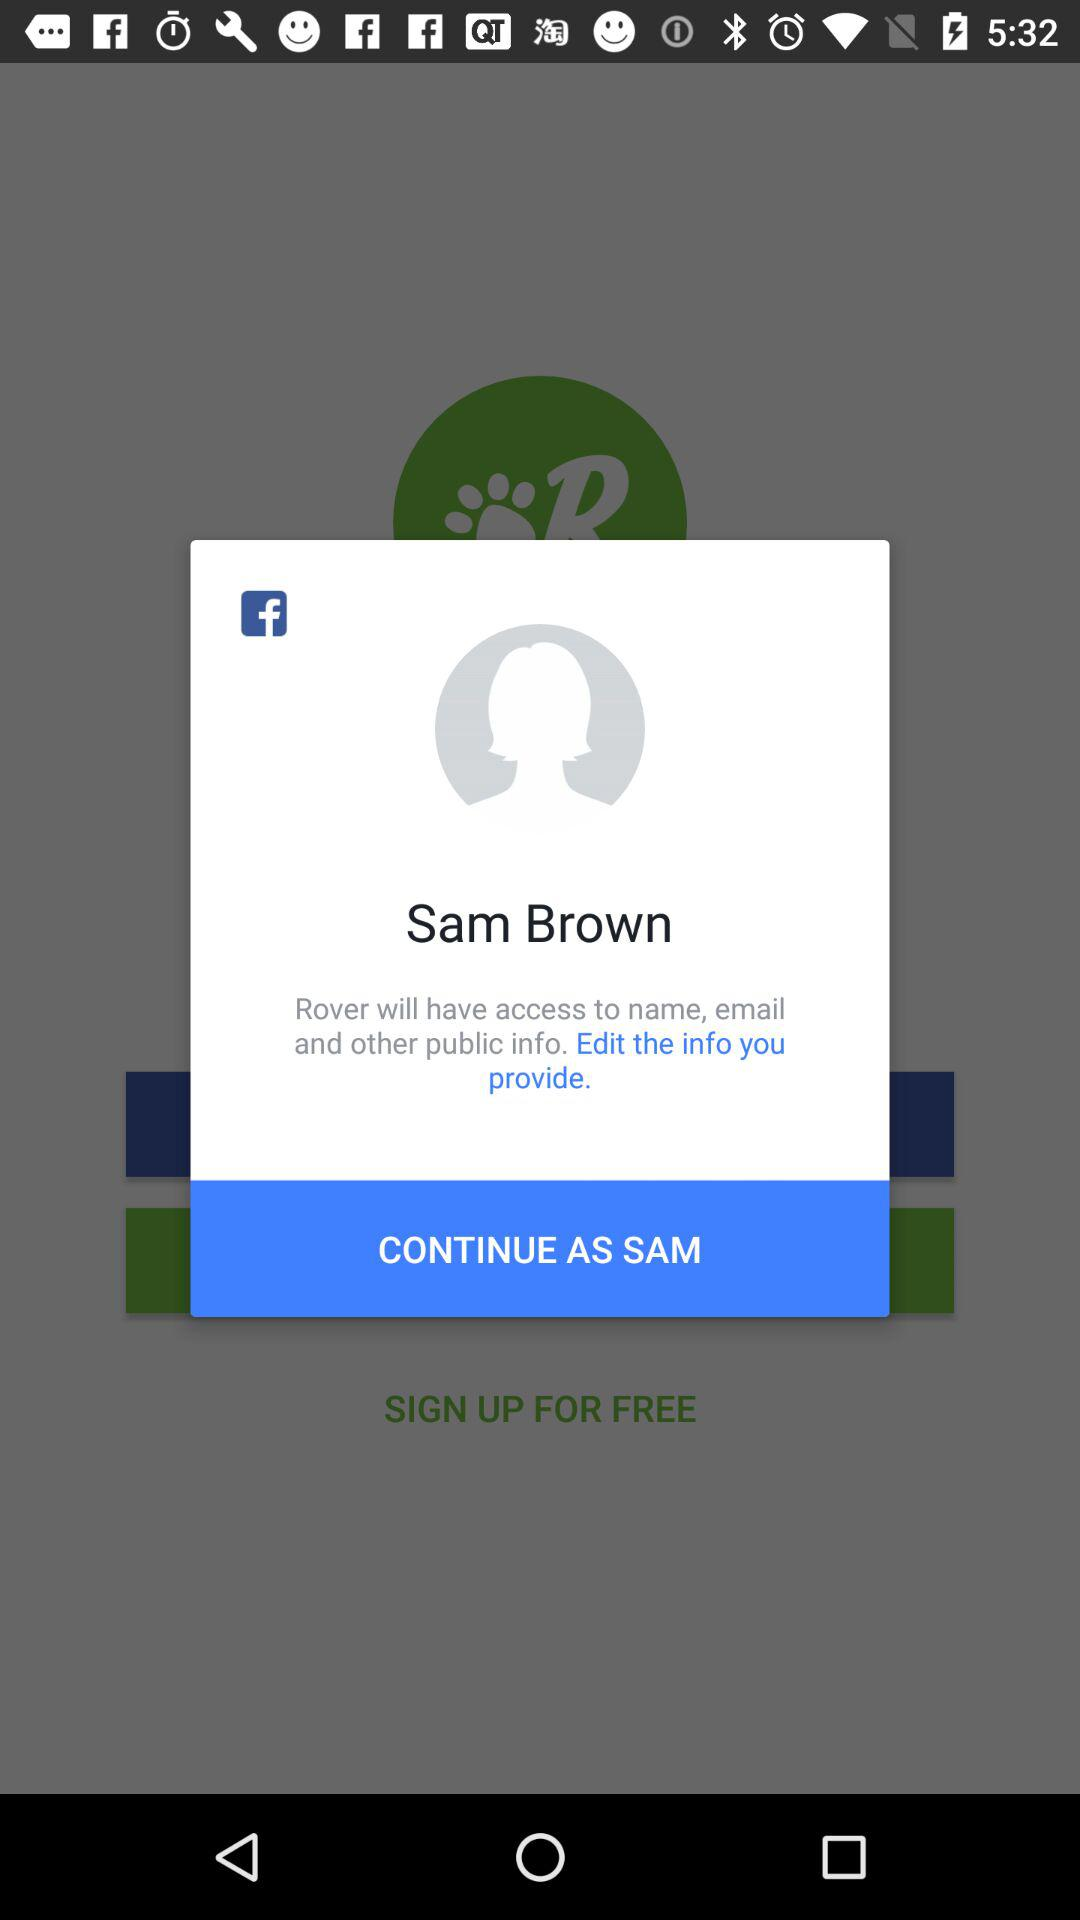What is the user name? The user name is Sam Brown. 